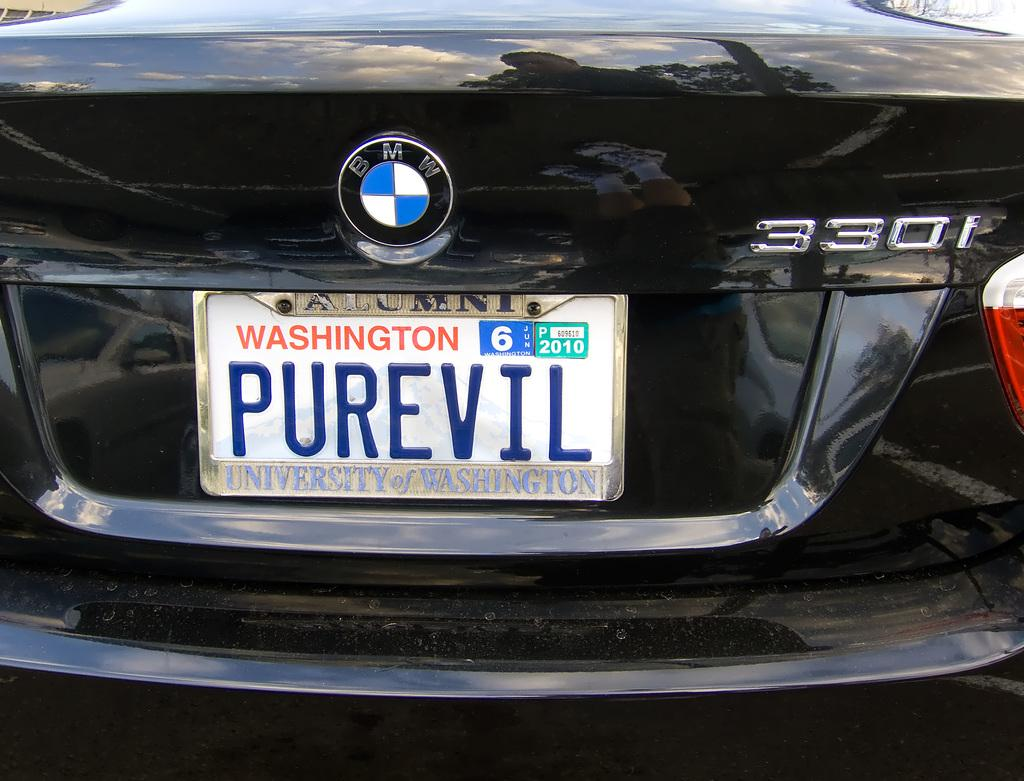Provide a one-sentence caption for the provided image. A black BMW with a Washington tag that says PUREVIL. 